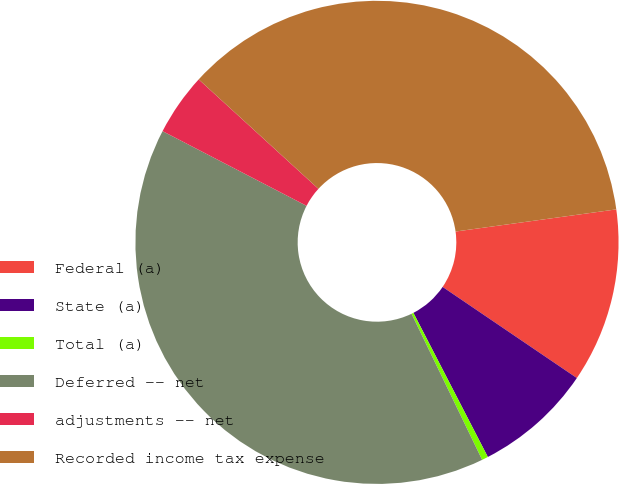Convert chart to OTSL. <chart><loc_0><loc_0><loc_500><loc_500><pie_chart><fcel>Federal (a)<fcel>State (a)<fcel>Total (a)<fcel>Deferred -- net<fcel>adjustments -- net<fcel>Recorded income tax expense<nl><fcel>11.67%<fcel>7.92%<fcel>0.42%<fcel>39.78%<fcel>4.17%<fcel>36.03%<nl></chart> 